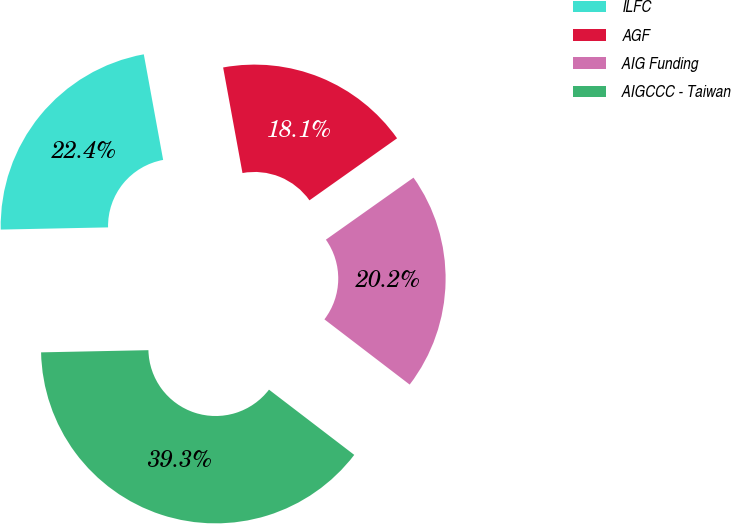Convert chart. <chart><loc_0><loc_0><loc_500><loc_500><pie_chart><fcel>ILFC<fcel>AGF<fcel>AIG Funding<fcel>AIGCCC - Taiwan<nl><fcel>22.44%<fcel>18.08%<fcel>20.2%<fcel>39.28%<nl></chart> 